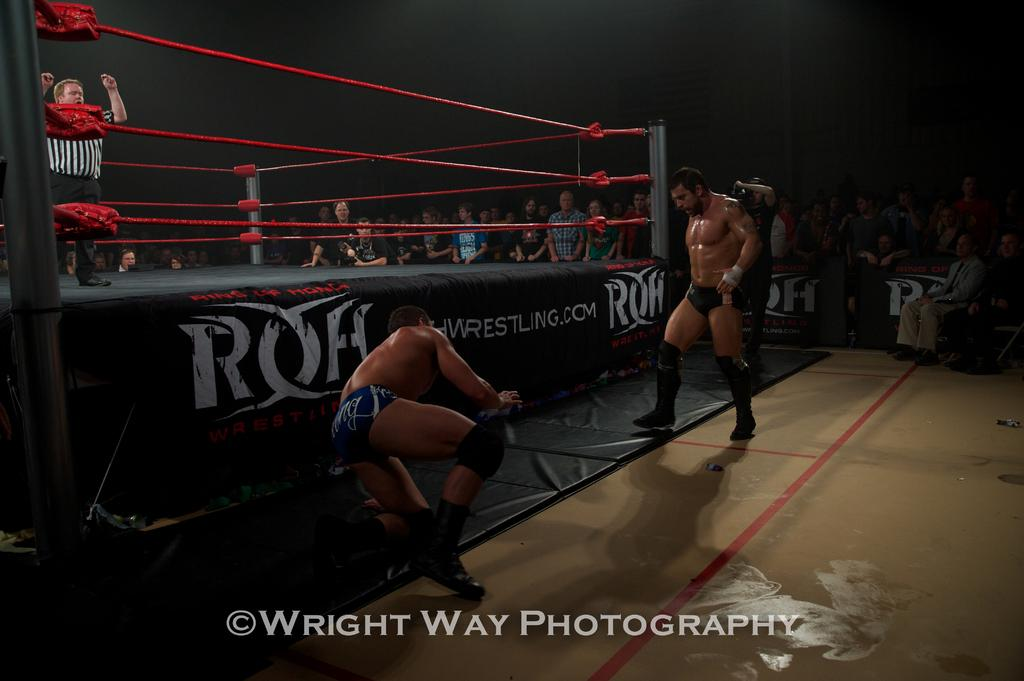<image>
Render a clear and concise summary of the photo. Two professional wrestlers fight outside the ring by Wright Way Photography. 